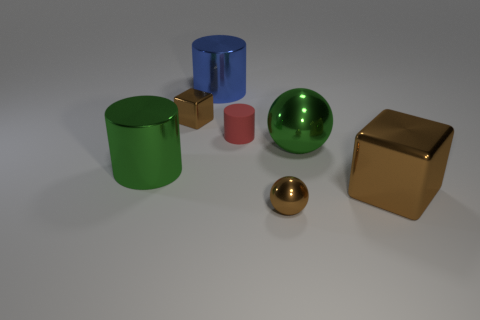How many other large spheres are the same color as the large ball?
Ensure brevity in your answer.  0. Are there fewer metallic cylinders that are behind the big green metallic sphere than big metallic cylinders right of the big brown object?
Ensure brevity in your answer.  No. There is a metal block behind the red object; what size is it?
Provide a short and direct response. Small. What size is the shiny ball that is the same color as the big metal cube?
Keep it short and to the point. Small. Is there a blue thing that has the same material as the big green cylinder?
Your answer should be very brief. Yes. Do the small red cylinder and the large green cylinder have the same material?
Your answer should be very brief. No. There is a cube that is the same size as the green ball; what is its color?
Ensure brevity in your answer.  Brown. What number of other objects are there of the same shape as the rubber object?
Your response must be concise. 2. There is a red rubber object; does it have the same size as the brown metallic block behind the large brown object?
Your answer should be compact. Yes. What number of objects are either tiny objects or large shiny spheres?
Offer a very short reply. 4. 